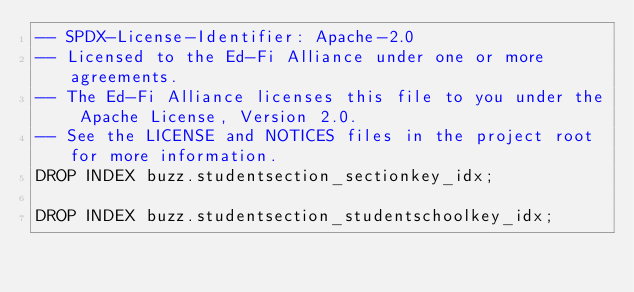<code> <loc_0><loc_0><loc_500><loc_500><_SQL_>-- SPDX-License-Identifier: Apache-2.0
-- Licensed to the Ed-Fi Alliance under one or more agreements.
-- The Ed-Fi Alliance licenses this file to you under the Apache License, Version 2.0.
-- See the LICENSE and NOTICES files in the project root for more information.
DROP INDEX buzz.studentsection_sectionkey_idx;

DROP INDEX buzz.studentsection_studentschoolkey_idx;
</code> 